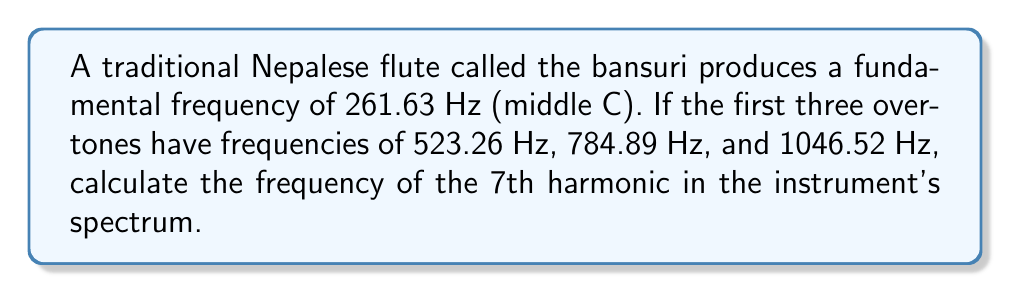Solve this math problem. To solve this problem, let's follow these steps:

1. Understand the harmonic series:
   The frequencies in a harmonic series are integer multiples of the fundamental frequency.

2. Identify the given information:
   - Fundamental frequency (1st harmonic): $f_1 = 261.63$ Hz
   - 2nd harmonic: $f_2 = 523.26$ Hz
   - 3rd harmonic: $f_3 = 784.89$ Hz
   - 4th harmonic: $f_4 = 1046.52$ Hz

3. Verify the harmonic relationship:
   $f_2 = 2f_1 = 2 \times 261.63 = 523.26$ Hz
   $f_3 = 3f_1 = 3 \times 261.63 = 784.89$ Hz
   $f_4 = 4f_1 = 4 \times 261.63 = 1046.52$ Hz

4. Determine the general formula for the nth harmonic:
   $f_n = n \times f_1$

5. Calculate the 7th harmonic:
   $f_7 = 7 \times f_1 = 7 \times 261.63 = 1831.41$ Hz

Therefore, the frequency of the 7th harmonic in the bansuri's spectrum is 1831.41 Hz.
Answer: 1831.41 Hz 